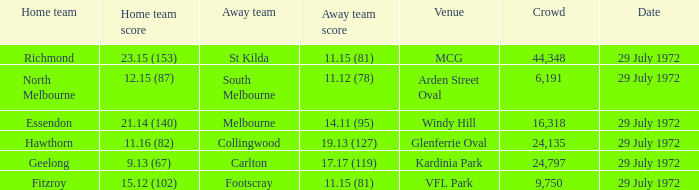When did the away team footscray score 11.15 (81)? 29 July 1972. 